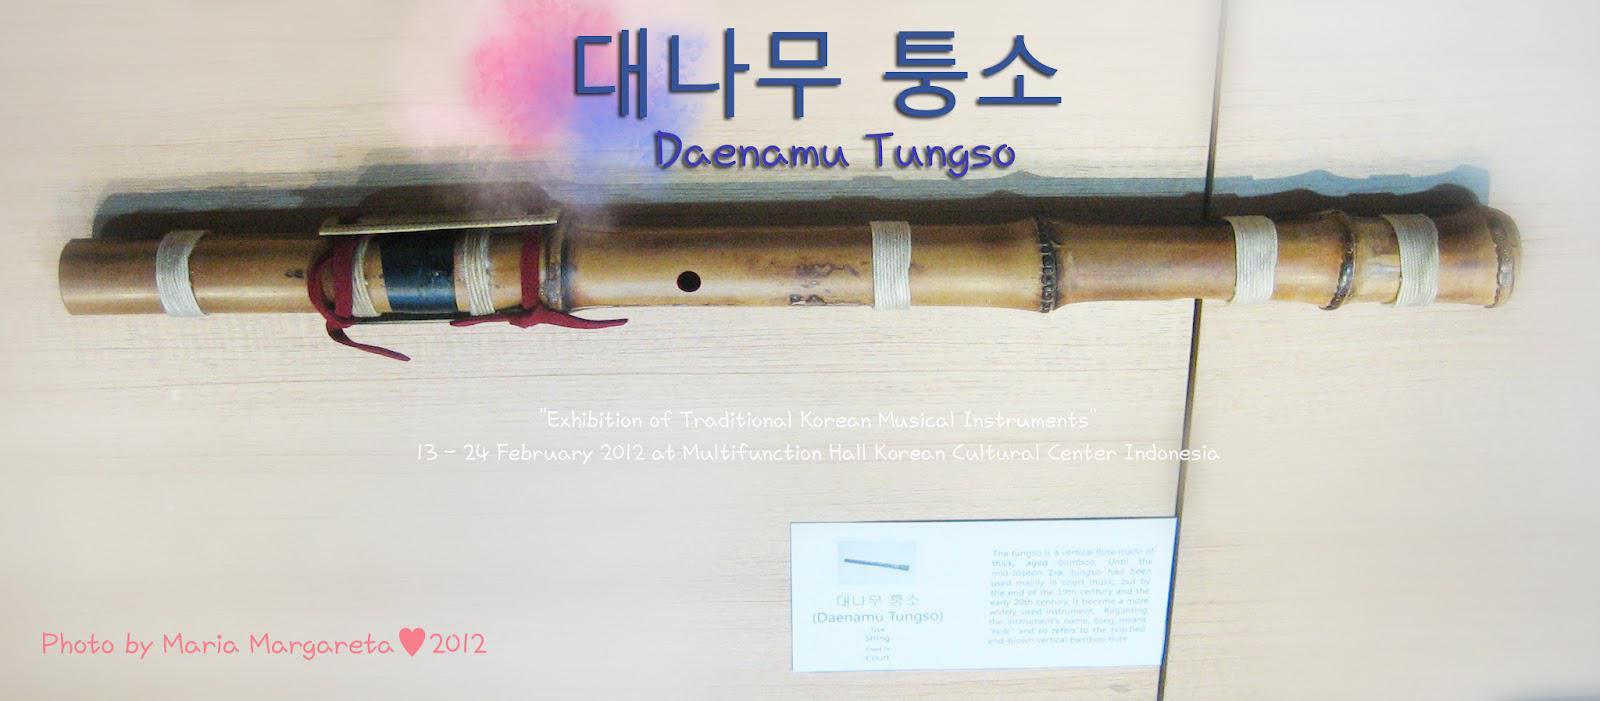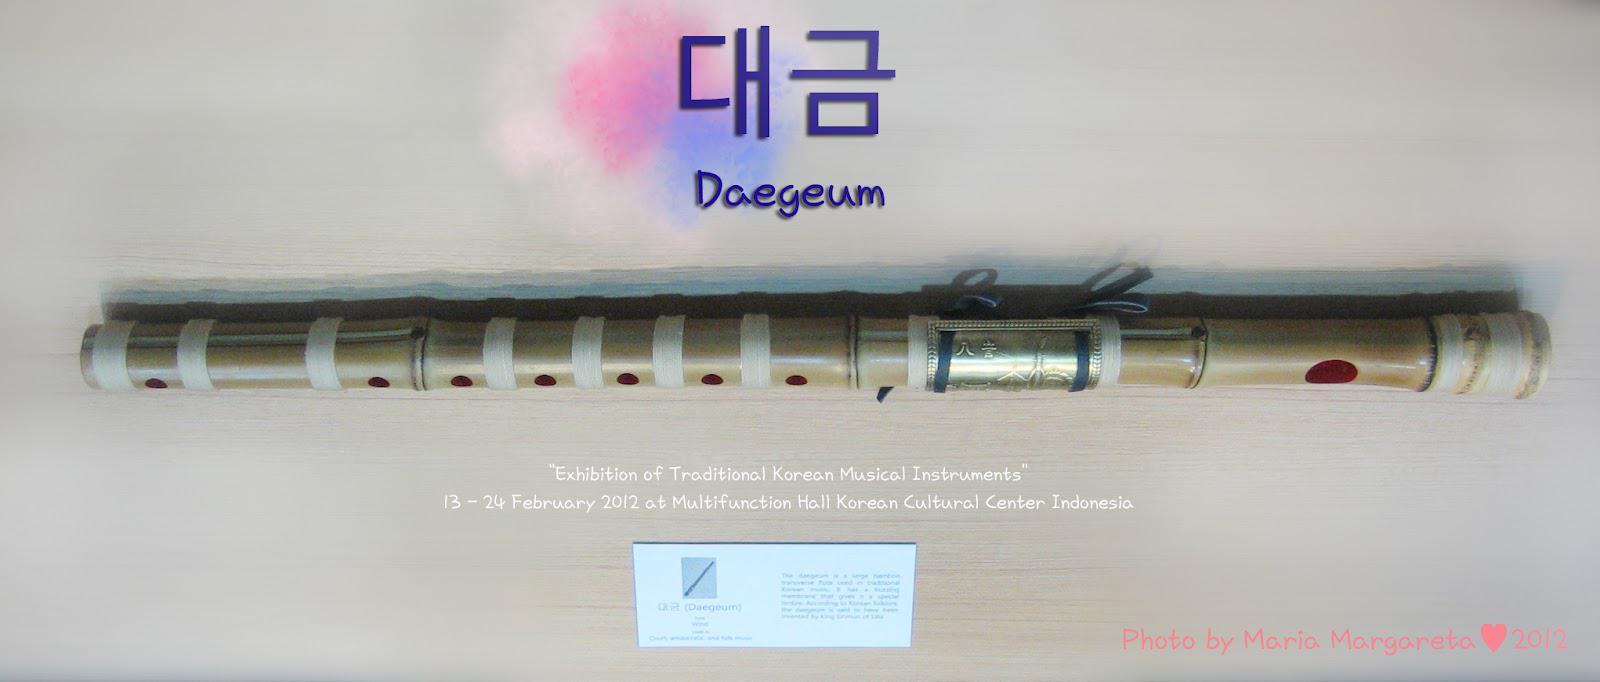The first image is the image on the left, the second image is the image on the right. Assess this claim about the two images: "Each image shows one bamboo flute displayed horizontally above a white card and beneath Asian characters superimposed over pink and blue color patches.". Correct or not? Answer yes or no. Yes. The first image is the image on the left, the second image is the image on the right. For the images shown, is this caption "Each of the instruments has an information card next to it." true? Answer yes or no. Yes. 